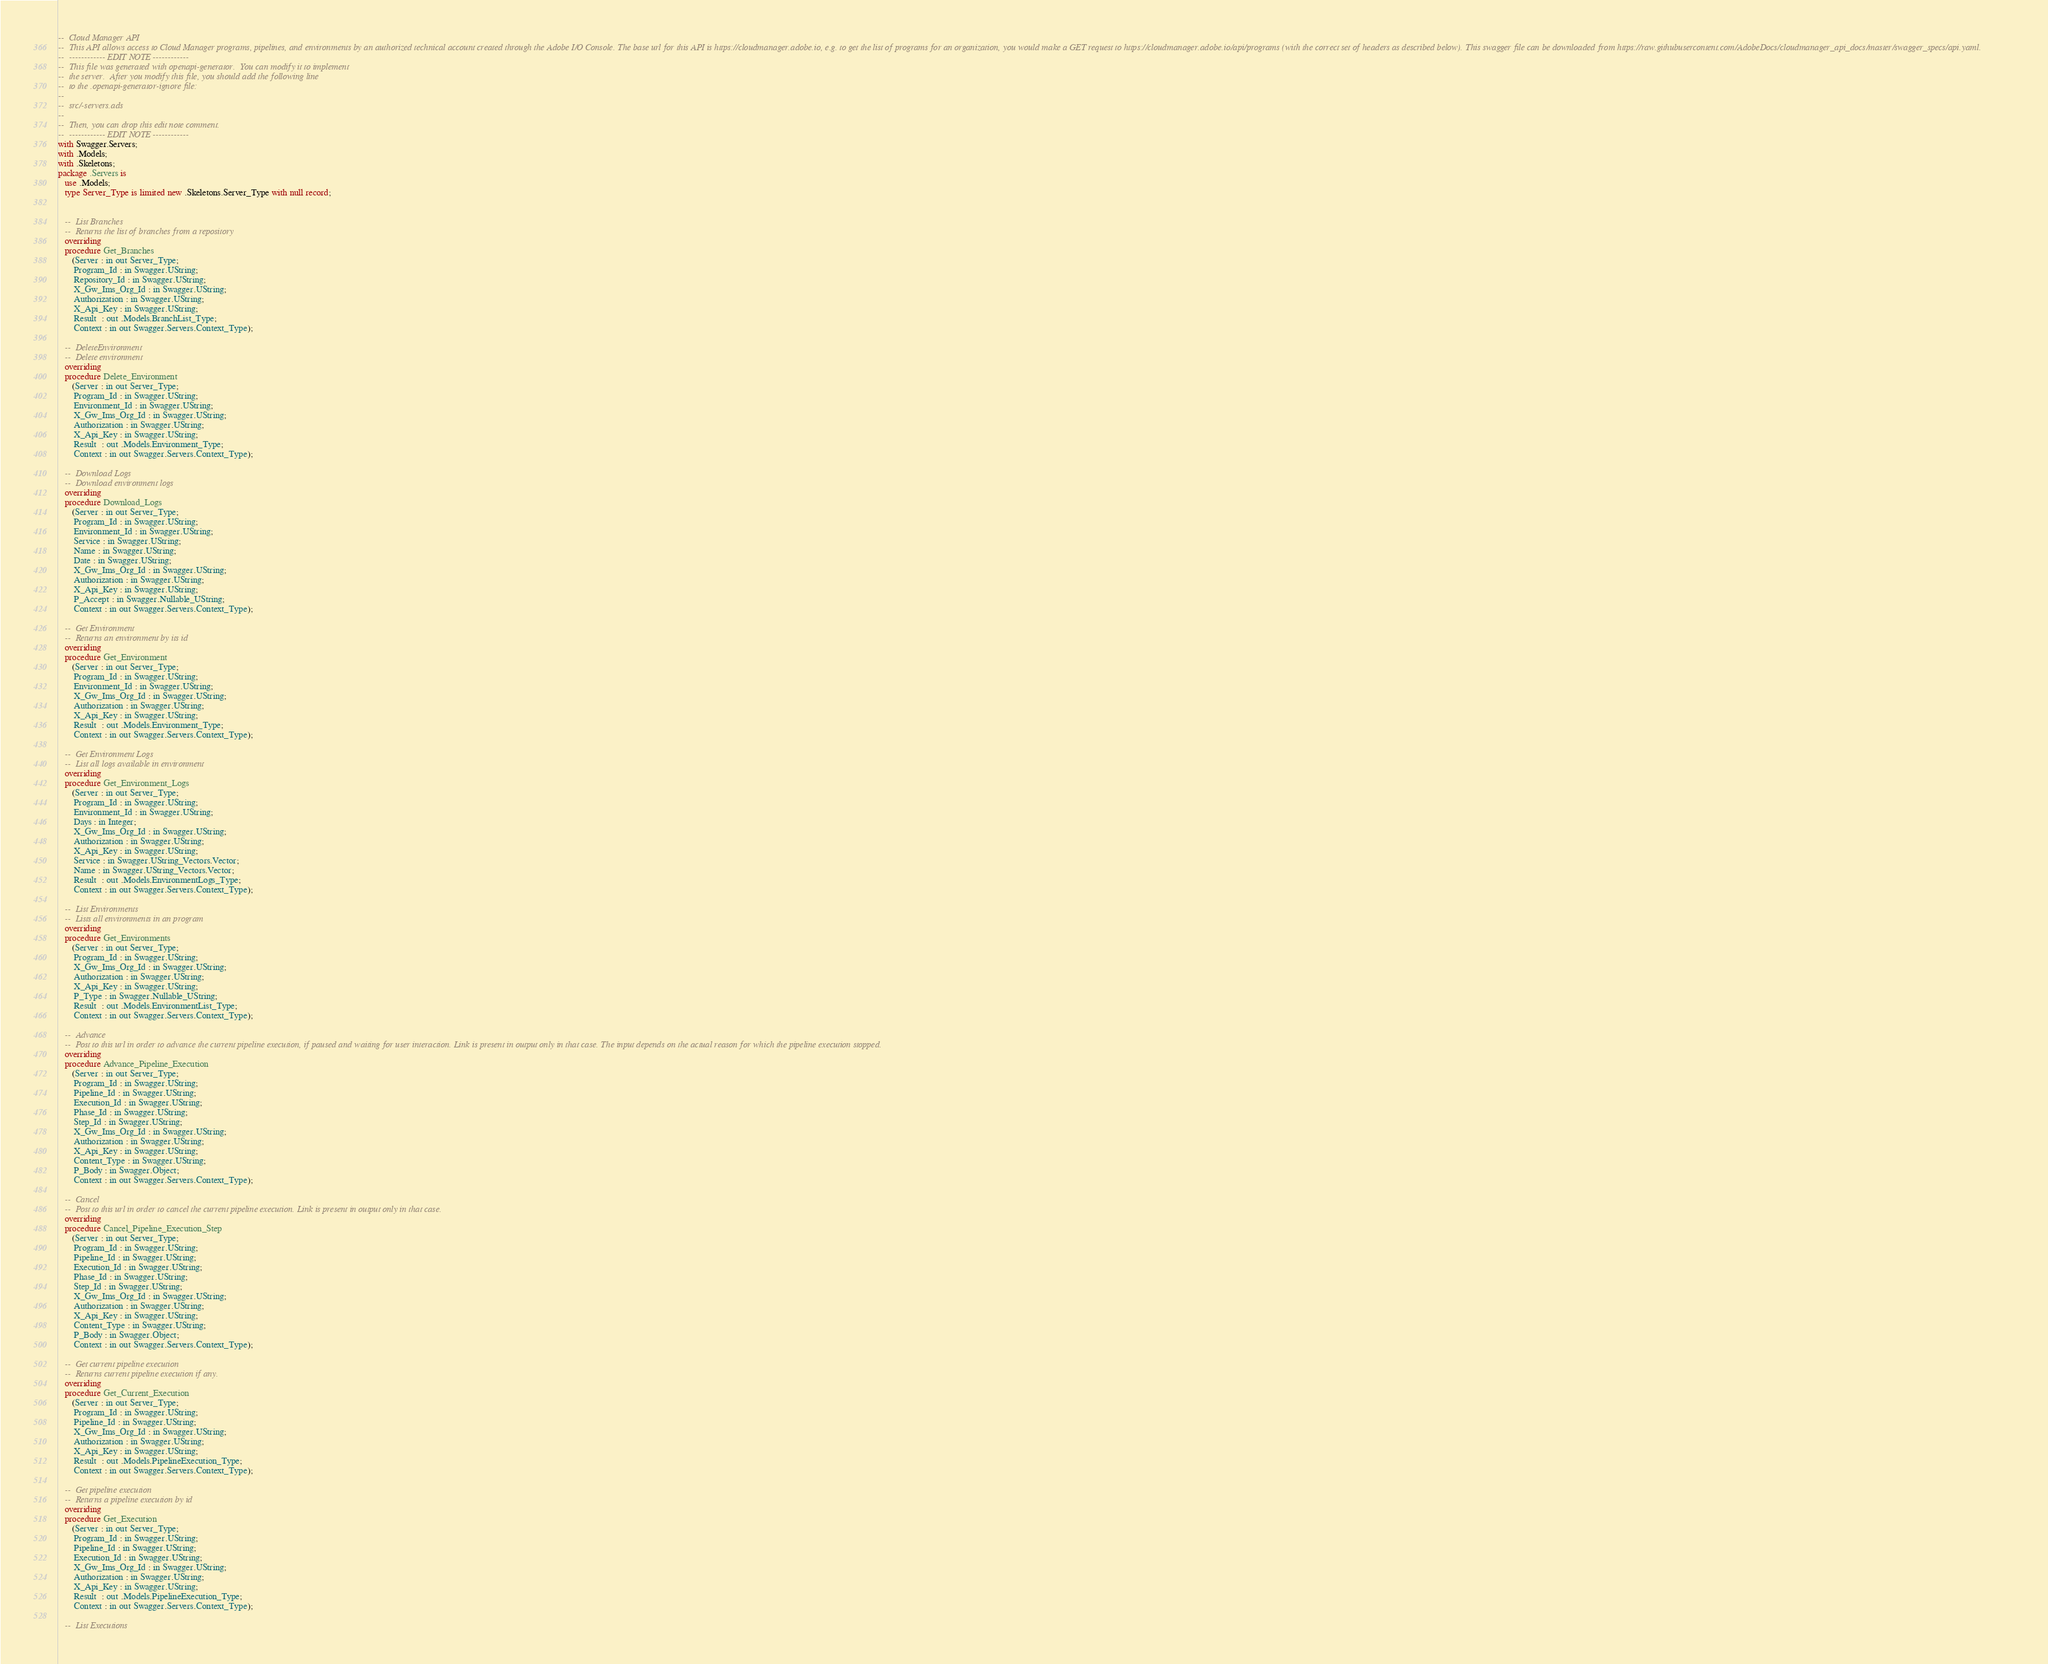<code> <loc_0><loc_0><loc_500><loc_500><_Ada_>--  Cloud Manager API
--  This API allows access to Cloud Manager programs, pipelines, and environments by an authorized technical account created through the Adobe I/O Console. The base url for this API is https://cloudmanager.adobe.io, e.g. to get the list of programs for an organization, you would make a GET request to https://cloudmanager.adobe.io/api/programs (with the correct set of headers as described below). This swagger file can be downloaded from https://raw.githubusercontent.com/AdobeDocs/cloudmanager_api_docs/master/swagger_specs/api.yaml.
--  ------------ EDIT NOTE ------------
--  This file was generated with openapi-generator.  You can modify it to implement
--  the server.  After you modify this file, you should add the following line
--  to the .openapi-generator-ignore file:
--
--  src/-servers.ads
--
--  Then, you can drop this edit note comment.
--  ------------ EDIT NOTE ------------
with Swagger.Servers;
with .Models;
with .Skeletons;
package .Servers is
   use .Models;
   type Server_Type is limited new .Skeletons.Server_Type with null record;


   --  List Branches
   --  Returns the list of branches from a repository
   overriding
   procedure Get_Branches
      (Server : in out Server_Type;
       Program_Id : in Swagger.UString;
       Repository_Id : in Swagger.UString;
       X_Gw_Ims_Org_Id : in Swagger.UString;
       Authorization : in Swagger.UString;
       X_Api_Key : in Swagger.UString;
       Result  : out .Models.BranchList_Type;
       Context : in out Swagger.Servers.Context_Type);

   --  DeleteEnvironment
   --  Delete environment
   overriding
   procedure Delete_Environment
      (Server : in out Server_Type;
       Program_Id : in Swagger.UString;
       Environment_Id : in Swagger.UString;
       X_Gw_Ims_Org_Id : in Swagger.UString;
       Authorization : in Swagger.UString;
       X_Api_Key : in Swagger.UString;
       Result  : out .Models.Environment_Type;
       Context : in out Swagger.Servers.Context_Type);

   --  Download Logs
   --  Download environment logs
   overriding
   procedure Download_Logs
      (Server : in out Server_Type;
       Program_Id : in Swagger.UString;
       Environment_Id : in Swagger.UString;
       Service : in Swagger.UString;
       Name : in Swagger.UString;
       Date : in Swagger.UString;
       X_Gw_Ims_Org_Id : in Swagger.UString;
       Authorization : in Swagger.UString;
       X_Api_Key : in Swagger.UString;
       P_Accept : in Swagger.Nullable_UString;
       Context : in out Swagger.Servers.Context_Type);

   --  Get Environment
   --  Returns an environment by its id
   overriding
   procedure Get_Environment
      (Server : in out Server_Type;
       Program_Id : in Swagger.UString;
       Environment_Id : in Swagger.UString;
       X_Gw_Ims_Org_Id : in Swagger.UString;
       Authorization : in Swagger.UString;
       X_Api_Key : in Swagger.UString;
       Result  : out .Models.Environment_Type;
       Context : in out Swagger.Servers.Context_Type);

   --  Get Environment Logs
   --  List all logs available in environment
   overriding
   procedure Get_Environment_Logs
      (Server : in out Server_Type;
       Program_Id : in Swagger.UString;
       Environment_Id : in Swagger.UString;
       Days : in Integer;
       X_Gw_Ims_Org_Id : in Swagger.UString;
       Authorization : in Swagger.UString;
       X_Api_Key : in Swagger.UString;
       Service : in Swagger.UString_Vectors.Vector;
       Name : in Swagger.UString_Vectors.Vector;
       Result  : out .Models.EnvironmentLogs_Type;
       Context : in out Swagger.Servers.Context_Type);

   --  List Environments
   --  Lists all environments in an program
   overriding
   procedure Get_Environments
      (Server : in out Server_Type;
       Program_Id : in Swagger.UString;
       X_Gw_Ims_Org_Id : in Swagger.UString;
       Authorization : in Swagger.UString;
       X_Api_Key : in Swagger.UString;
       P_Type : in Swagger.Nullable_UString;
       Result  : out .Models.EnvironmentList_Type;
       Context : in out Swagger.Servers.Context_Type);

   --  Advance
   --  Post to this url in order to advance the current pipeline execution, if paused and waiting for user interaction. Link is present in output only in that case. The input depends on the actual reason for which the pipeline execution stopped.
   overriding
   procedure Advance_Pipeline_Execution
      (Server : in out Server_Type;
       Program_Id : in Swagger.UString;
       Pipeline_Id : in Swagger.UString;
       Execution_Id : in Swagger.UString;
       Phase_Id : in Swagger.UString;
       Step_Id : in Swagger.UString;
       X_Gw_Ims_Org_Id : in Swagger.UString;
       Authorization : in Swagger.UString;
       X_Api_Key : in Swagger.UString;
       Content_Type : in Swagger.UString;
       P_Body : in Swagger.Object;
       Context : in out Swagger.Servers.Context_Type);

   --  Cancel
   --  Post to this url in order to cancel the current pipeline execution. Link is present in output only in that case.
   overriding
   procedure Cancel_Pipeline_Execution_Step
      (Server : in out Server_Type;
       Program_Id : in Swagger.UString;
       Pipeline_Id : in Swagger.UString;
       Execution_Id : in Swagger.UString;
       Phase_Id : in Swagger.UString;
       Step_Id : in Swagger.UString;
       X_Gw_Ims_Org_Id : in Swagger.UString;
       Authorization : in Swagger.UString;
       X_Api_Key : in Swagger.UString;
       Content_Type : in Swagger.UString;
       P_Body : in Swagger.Object;
       Context : in out Swagger.Servers.Context_Type);

   --  Get current pipeline execution
   --  Returns current pipeline execution if any.
   overriding
   procedure Get_Current_Execution
      (Server : in out Server_Type;
       Program_Id : in Swagger.UString;
       Pipeline_Id : in Swagger.UString;
       X_Gw_Ims_Org_Id : in Swagger.UString;
       Authorization : in Swagger.UString;
       X_Api_Key : in Swagger.UString;
       Result  : out .Models.PipelineExecution_Type;
       Context : in out Swagger.Servers.Context_Type);

   --  Get pipeline execution
   --  Returns a pipeline execution by id
   overriding
   procedure Get_Execution
      (Server : in out Server_Type;
       Program_Id : in Swagger.UString;
       Pipeline_Id : in Swagger.UString;
       Execution_Id : in Swagger.UString;
       X_Gw_Ims_Org_Id : in Swagger.UString;
       Authorization : in Swagger.UString;
       X_Api_Key : in Swagger.UString;
       Result  : out .Models.PipelineExecution_Type;
       Context : in out Swagger.Servers.Context_Type);

   --  List Executions</code> 